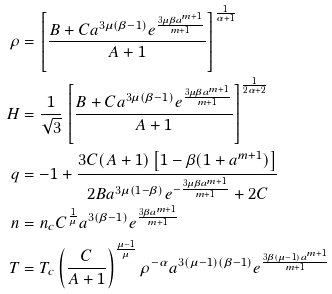<formula> <loc_0><loc_0><loc_500><loc_500>\rho & = \left [ \frac { B + C a ^ { 3 \mu ( \beta - 1 ) } e ^ { \frac { 3 \mu \beta a ^ { m + 1 } } { m + 1 } } } { A + 1 } \right ] ^ { \frac { 1 } { \alpha + 1 } } \\ H & = \frac { 1 } { \sqrt { 3 } } \left [ \frac { B + C a ^ { 3 \mu ( \beta - 1 ) } e ^ { \frac { 3 \mu \beta a ^ { m + 1 } } { m + 1 } } } { A + 1 } \right ] ^ { \frac { 1 } { 2 \alpha + 2 } } \\ q & = - 1 + \frac { 3 C ( A + 1 ) \left [ 1 - \beta ( 1 + a ^ { m + 1 } ) \right ] } { 2 B a ^ { 3 \mu ( 1 - \beta ) } e ^ { - \frac { 3 \mu \beta a ^ { m + 1 } } { m + 1 } } + 2 C } \\ n & = n _ { c } C ^ { \frac { 1 } { \mu } } a ^ { 3 ( \beta - 1 ) } e ^ { \frac { 3 \beta a ^ { m + 1 } } { m + 1 } } \\ T & = T _ { c } \left ( \frac { C } { A + 1 } \right ) ^ { \frac { \mu - 1 } { \mu } } \rho ^ { - \alpha } a ^ { 3 ( \mu - 1 ) ( \beta - 1 ) } e ^ { \frac { 3 \beta ( \mu - 1 ) a ^ { m + 1 } } { m + 1 } }</formula> 